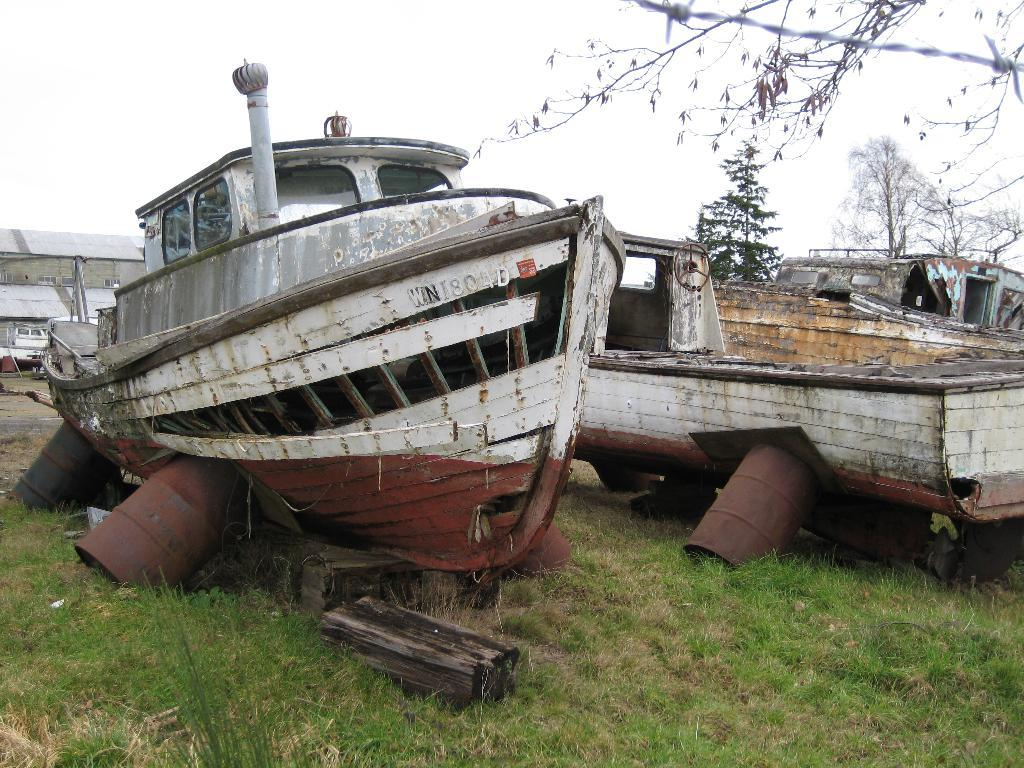What type of vehicles can be seen in the image? There are boats in the image. What type of vegetation is present in the image? There is grass and trees in the image. What type of structure can be seen in the image? There is a shed in the image. What is visible in the background of the image? The sky is visible in the background of the image. Can you see a frog using a comb on a page in the image? There is no frog, comb, or page present in the image. What type of creature might be found in the grass in the image? While it is possible that there could be creatures like insects or small animals in the grass, the image does not show any specific creatures. 